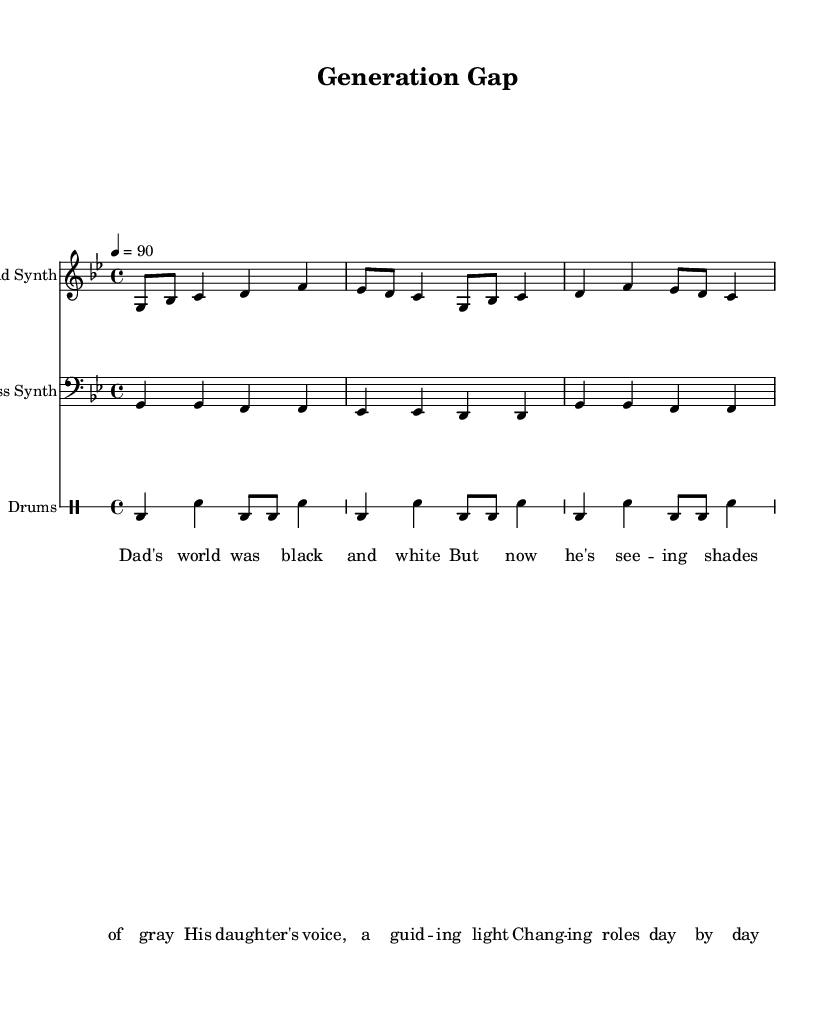What is the key signature of this music? The key signature is G minor, which has two flats (B♭ and E♭). This can be determined by looking at the key indication at the beginning of the sheet music.
Answer: G minor What is the time signature of this piece? The time signature is 4/4, as indicated by the symbol at the beginning of the sheet music, showing that there are four beats in each measure.
Answer: 4/4 What is the tempo marking for the piece? The tempo marking is 90, which is indicated above the staff, showing that the quarter note gets a beat of 90 bpm.
Answer: 90 How many measures does the lead synth section have? The lead synth section contains three measures of music, as counted from the notations shown. Each measure is delineated by vertical bar lines.
Answer: Three What instruments are involved in this score? The score includes a lead synth, bass synth, and drums, as specified in the instrument names at the beginning of each staff.
Answer: Lead synth, bass synth, and drums What thematic element is addressed in the lyrics? The lyrics address changing family dynamics, specifically how a father's perspective evolves through his daughter's influence, as seen in the content of the lines.
Answer: Changing family dynamics 